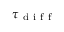Convert formula to latex. <formula><loc_0><loc_0><loc_500><loc_500>\tau _ { d i f f }</formula> 